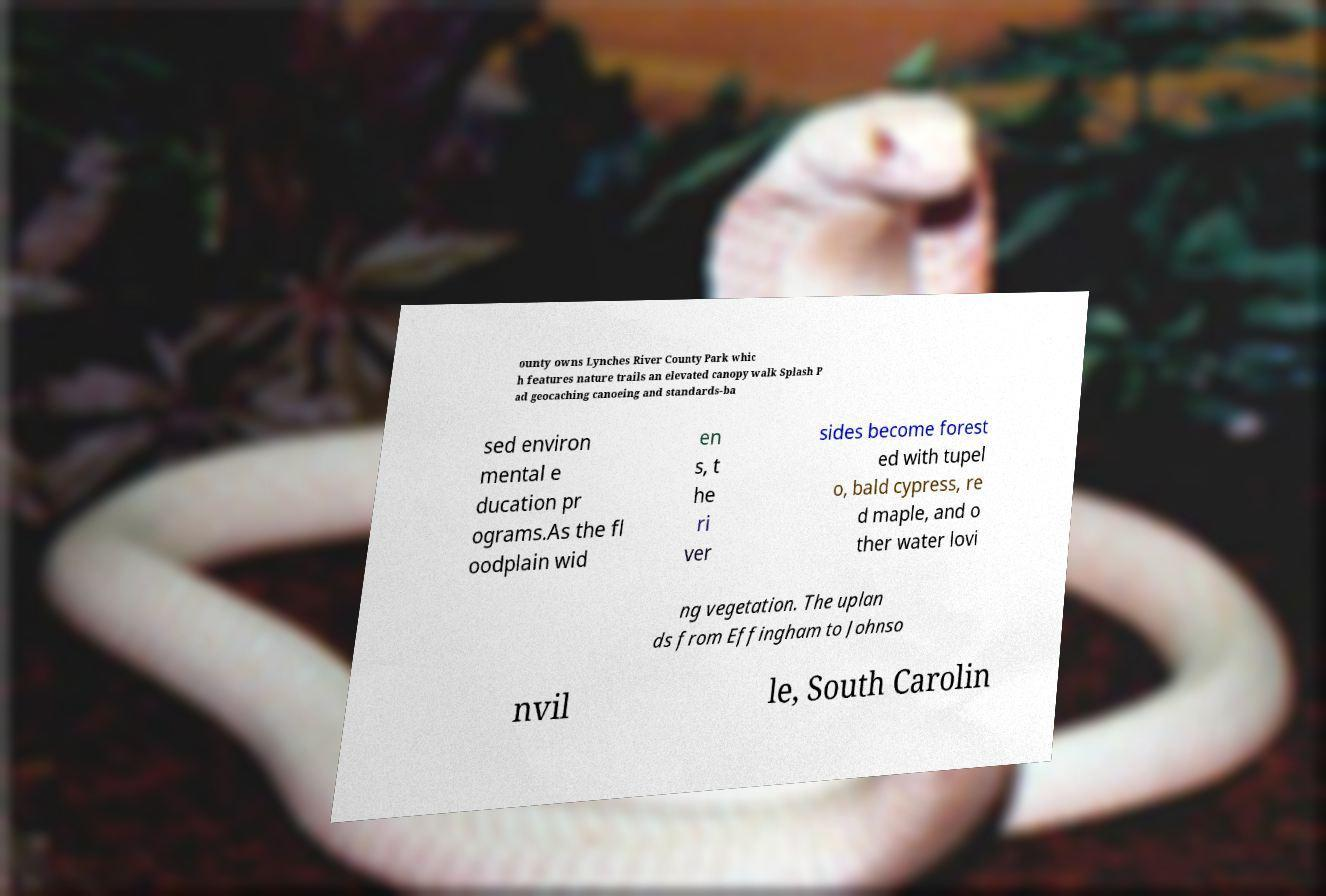What messages or text are displayed in this image? I need them in a readable, typed format. ounty owns Lynches River County Park whic h features nature trails an elevated canopy walk Splash P ad geocaching canoeing and standards-ba sed environ mental e ducation pr ograms.As the fl oodplain wid en s, t he ri ver sides become forest ed with tupel o, bald cypress, re d maple, and o ther water lovi ng vegetation. The uplan ds from Effingham to Johnso nvil le, South Carolin 